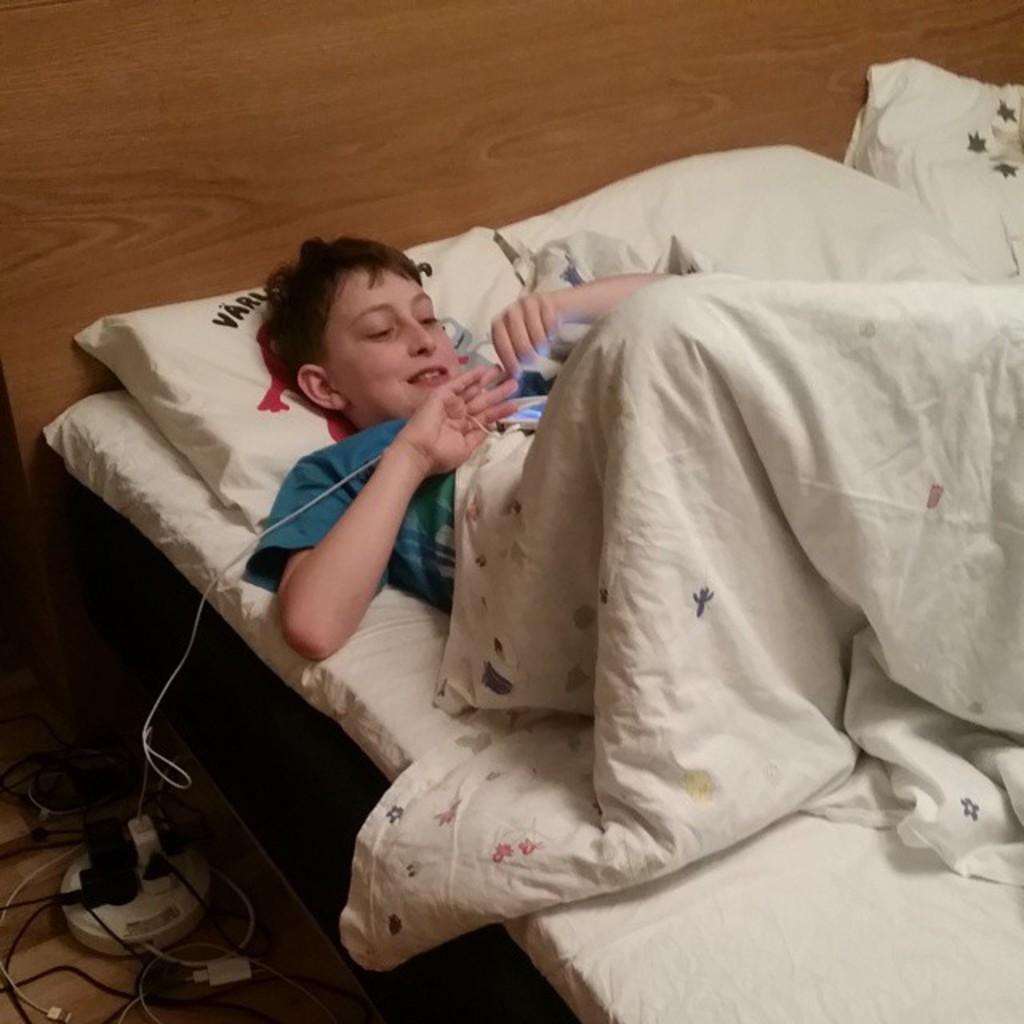Please provide a concise description of this image. In this image i can see a person a sat on the bed,and there are some pillows and his wearing a blanket and his smiling,and there are some cable cards on the floor. 